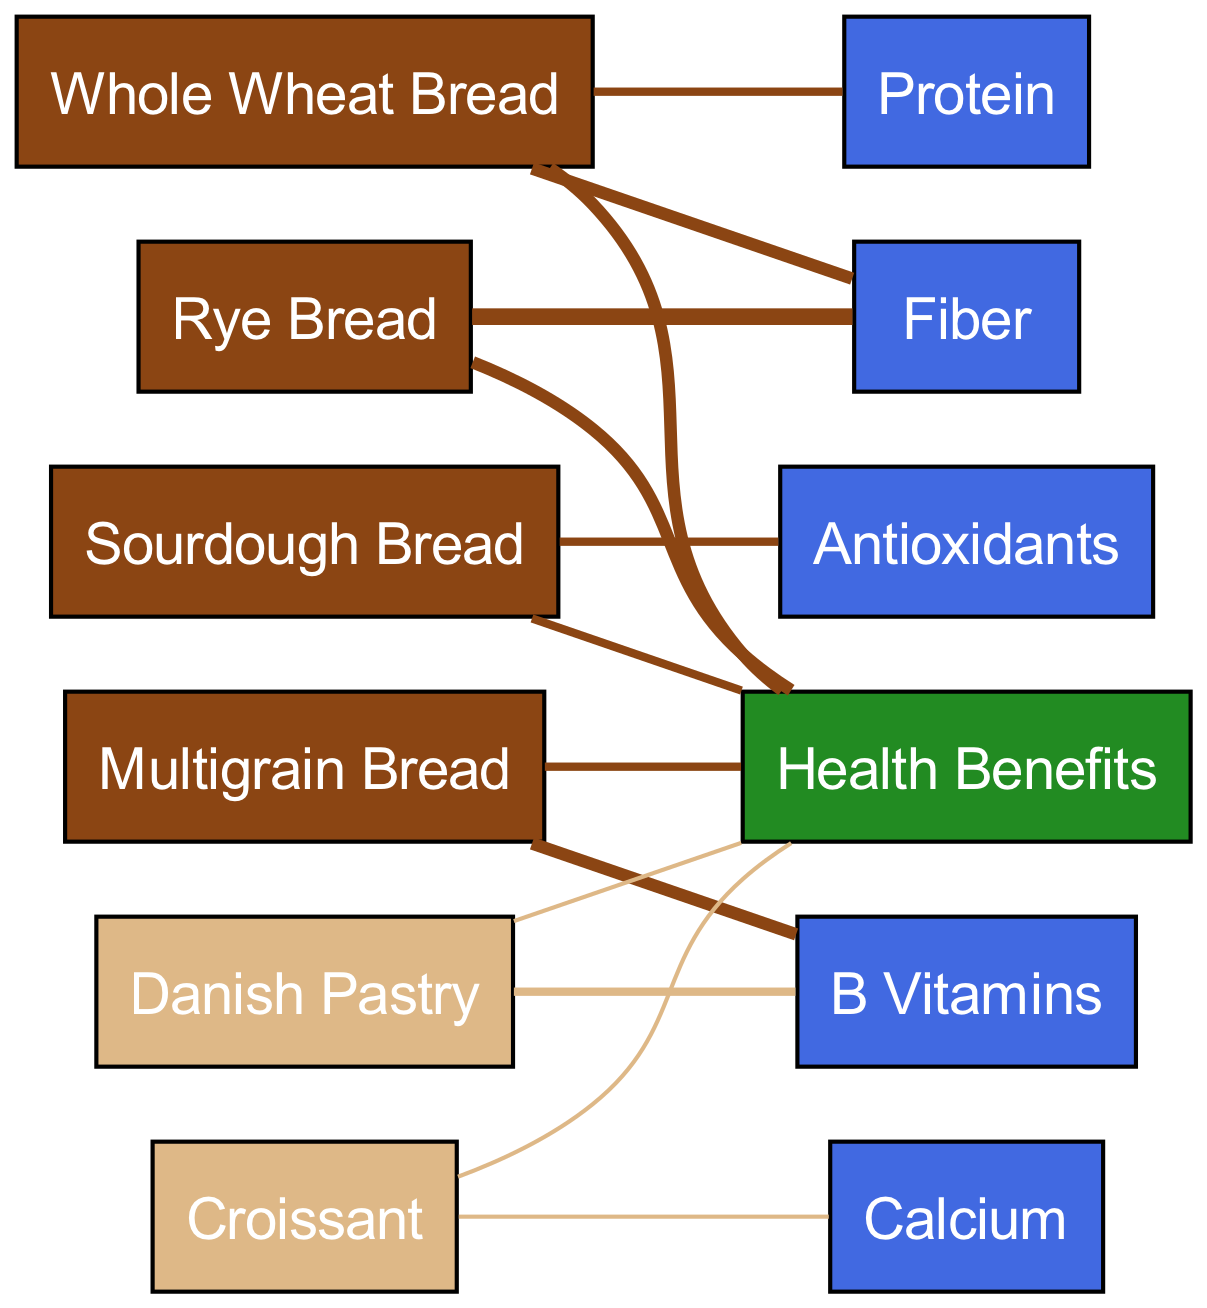What are the health benefits linked to whole wheat bread? Whole wheat bread has direct links to health benefits depicted in the diagram, indicating it contributes significantly to overall health. The value associated with this link is 3.
Answer: 3 Which type of bread provides the highest fiber? Looking at the diagram, rye bread links to fiber with a value of 4, which is the highest among all types of bread shown.
Answer: Rye Bread What is the total number of nodes in the diagram? The diagram has a total of 11 nodes, counting all distinct types of bread, pastries, health benefits, and nutrients.
Answer: 11 How many nutrients are associated with croissants? According to the diagram, croissants are associated with one specific nutrient, which is calcium.
Answer: 1 Which type of pastry has the most links to health benefits? The diagram indicates that both the Danish pastry and croissant each have one link to health benefits, showing they contribute equally in that regard.
Answer: 1 How many types of bread are linked to protein? In the diagram, there are two types of bread—whole wheat bread and rye bread—that have links to protein. This is determined by counting their direct relationships to the nutrient node of protein.
Answer: 2 What nutrient is uniquely associated with sourdough bread? The diagram shows that sourdough bread is uniquely associated with antioxidants, indicated by a direct link from sourdough to that nutrient node.
Answer: Antioxidants Which type of bread has the highest number of health benefits associated? When examining the diagram, both whole wheat bread and rye bread have the highest values, with each linked to health benefits with a value of 3.
Answer: Whole Wheat Bread, Rye Bread How many types of bread and pastries are depicted in total? The diagram reveals there are 6 types of bread and 2 types of pastries, leading to a total of 8 varieties represented in the nodes.
Answer: 8 